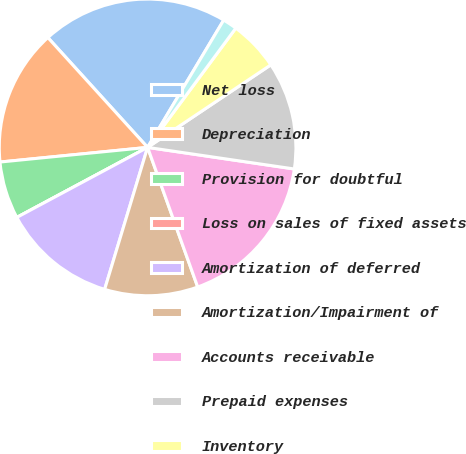Convert chart. <chart><loc_0><loc_0><loc_500><loc_500><pie_chart><fcel>Net loss<fcel>Depreciation<fcel>Provision for doubtful<fcel>Loss on sales of fixed assets<fcel>Amortization of deferred<fcel>Amortization/Impairment of<fcel>Accounts receivable<fcel>Prepaid expenses<fcel>Inventory<fcel>Other assets<nl><fcel>20.31%<fcel>14.84%<fcel>6.25%<fcel>0.0%<fcel>12.5%<fcel>10.16%<fcel>17.19%<fcel>11.72%<fcel>5.47%<fcel>1.56%<nl></chart> 